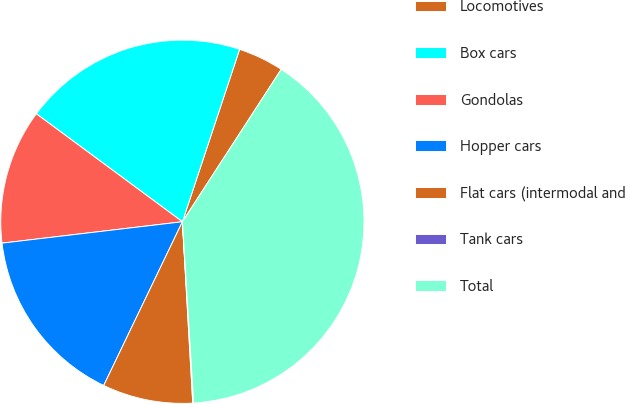Convert chart to OTSL. <chart><loc_0><loc_0><loc_500><loc_500><pie_chart><fcel>Locomotives<fcel>Box cars<fcel>Gondolas<fcel>Hopper cars<fcel>Flat cars (intermodal and<fcel>Tank cars<fcel>Total<nl><fcel>4.06%<fcel>19.97%<fcel>12.01%<fcel>15.99%<fcel>8.04%<fcel>0.08%<fcel>39.86%<nl></chart> 